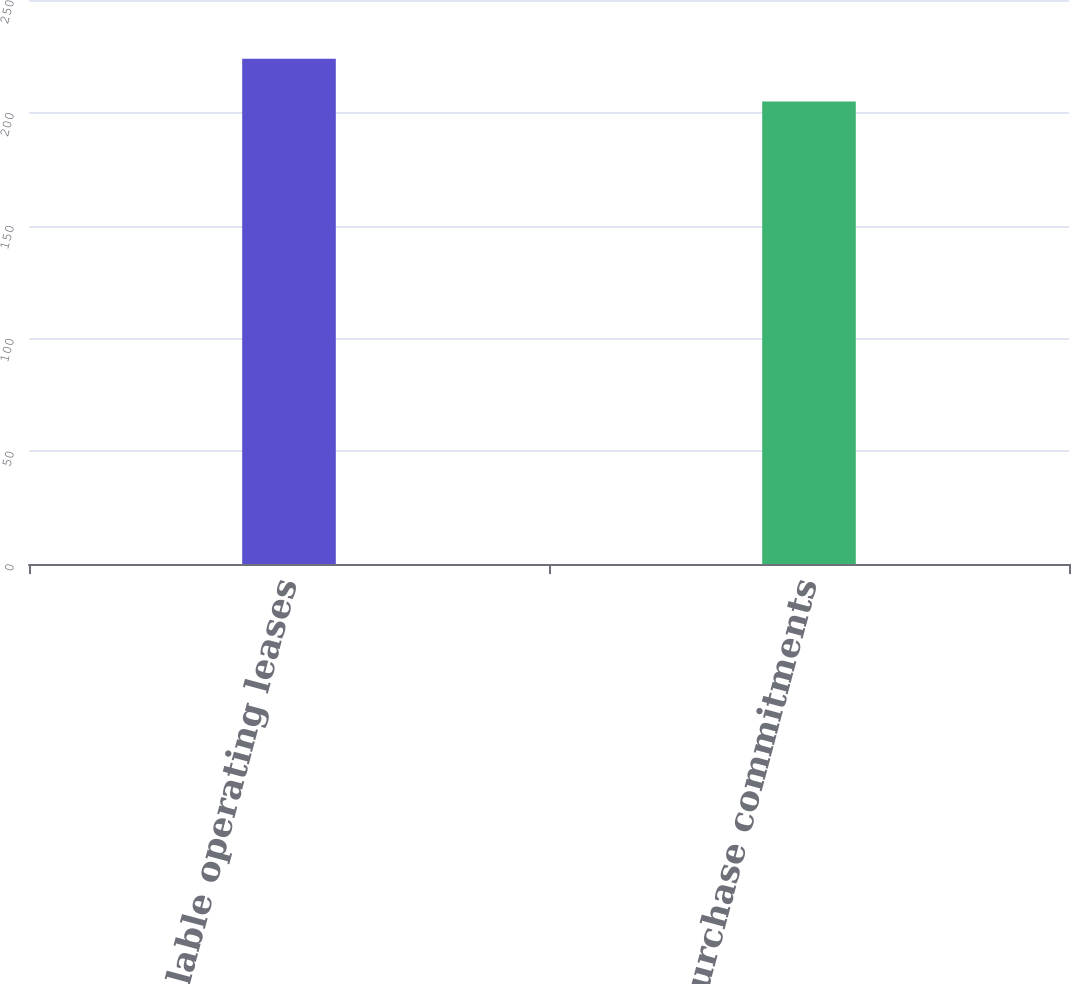Convert chart. <chart><loc_0><loc_0><loc_500><loc_500><bar_chart><fcel>Noncancelable operating leases<fcel>Other purchase commitments<nl><fcel>224<fcel>205<nl></chart> 